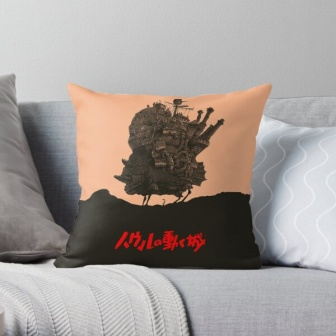Imagine a fantasy scenario involving the pillow, couch, and blanket. What happens? In a surreal fantasy scenario, the pillow's illustrated castle comes to life. As the sun sets, the room darkens and the outlines of the castle begin to glow softly. The whimsical towers start rising, and tiny, magical inhabitants begin to appear, bustling about their evening routines. The gray couch transforms into a vast, grassy plain surrounding the castle, with the blanket turning into a river winding through the scene. A miniature adventure unfolds as knights prepare for a feast, wizards perform spells, and creatures from various mythical lands gather to share stories. All this happens while the real-life room remains untouched, creating a hidden world within the familiar comfort of the home. 